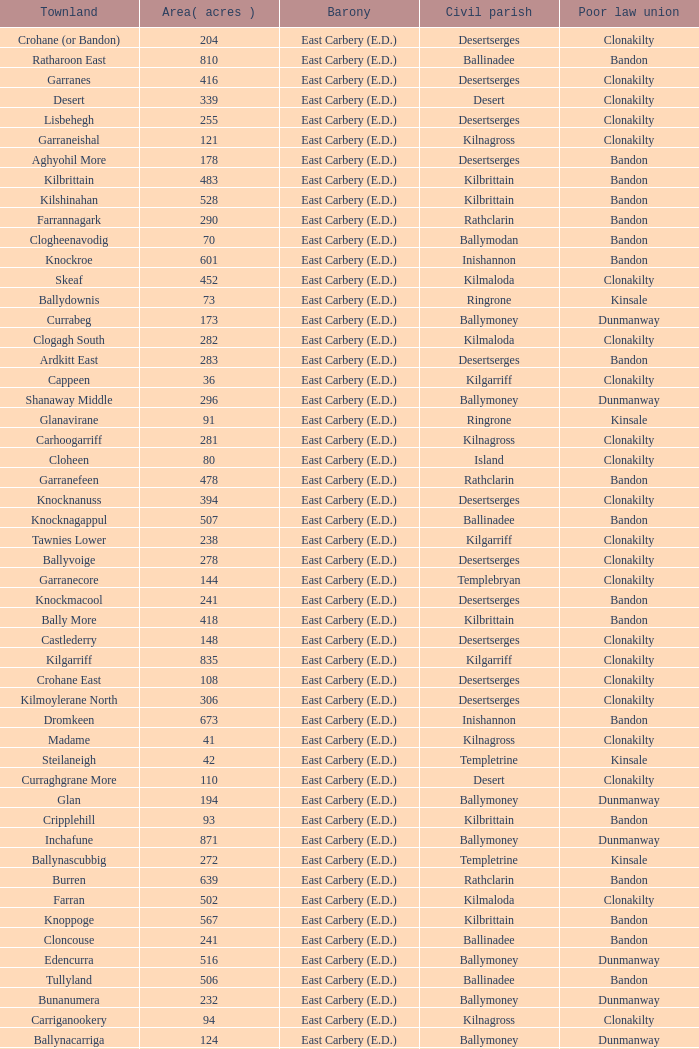What is the poor law union of the Ardacrow townland? Bandon. 